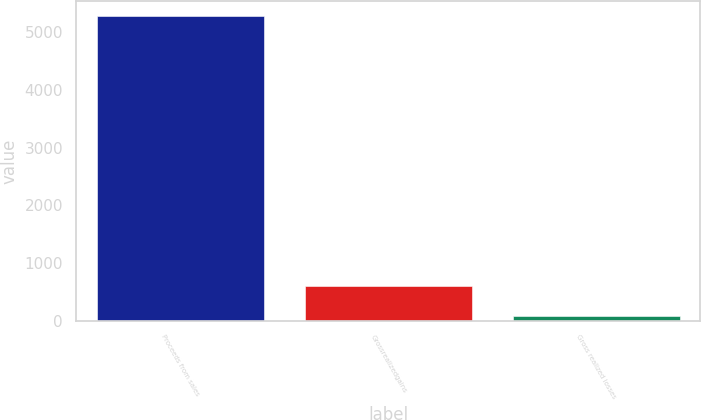Convert chart to OTSL. <chart><loc_0><loc_0><loc_500><loc_500><bar_chart><fcel>Proceeds from sales<fcel>Grossrealizedgains<fcel>Gross realized losses<nl><fcel>5274<fcel>600.3<fcel>81<nl></chart> 